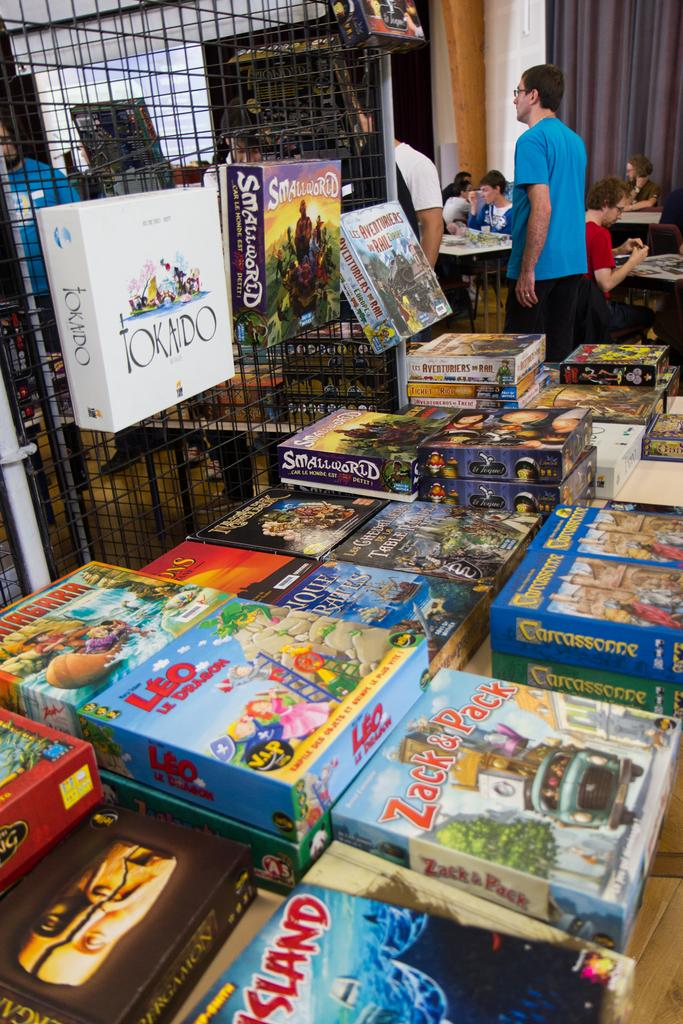<image>
Offer a succinct explanation of the picture presented. an assortment of puzzles and the bottom one saying island 